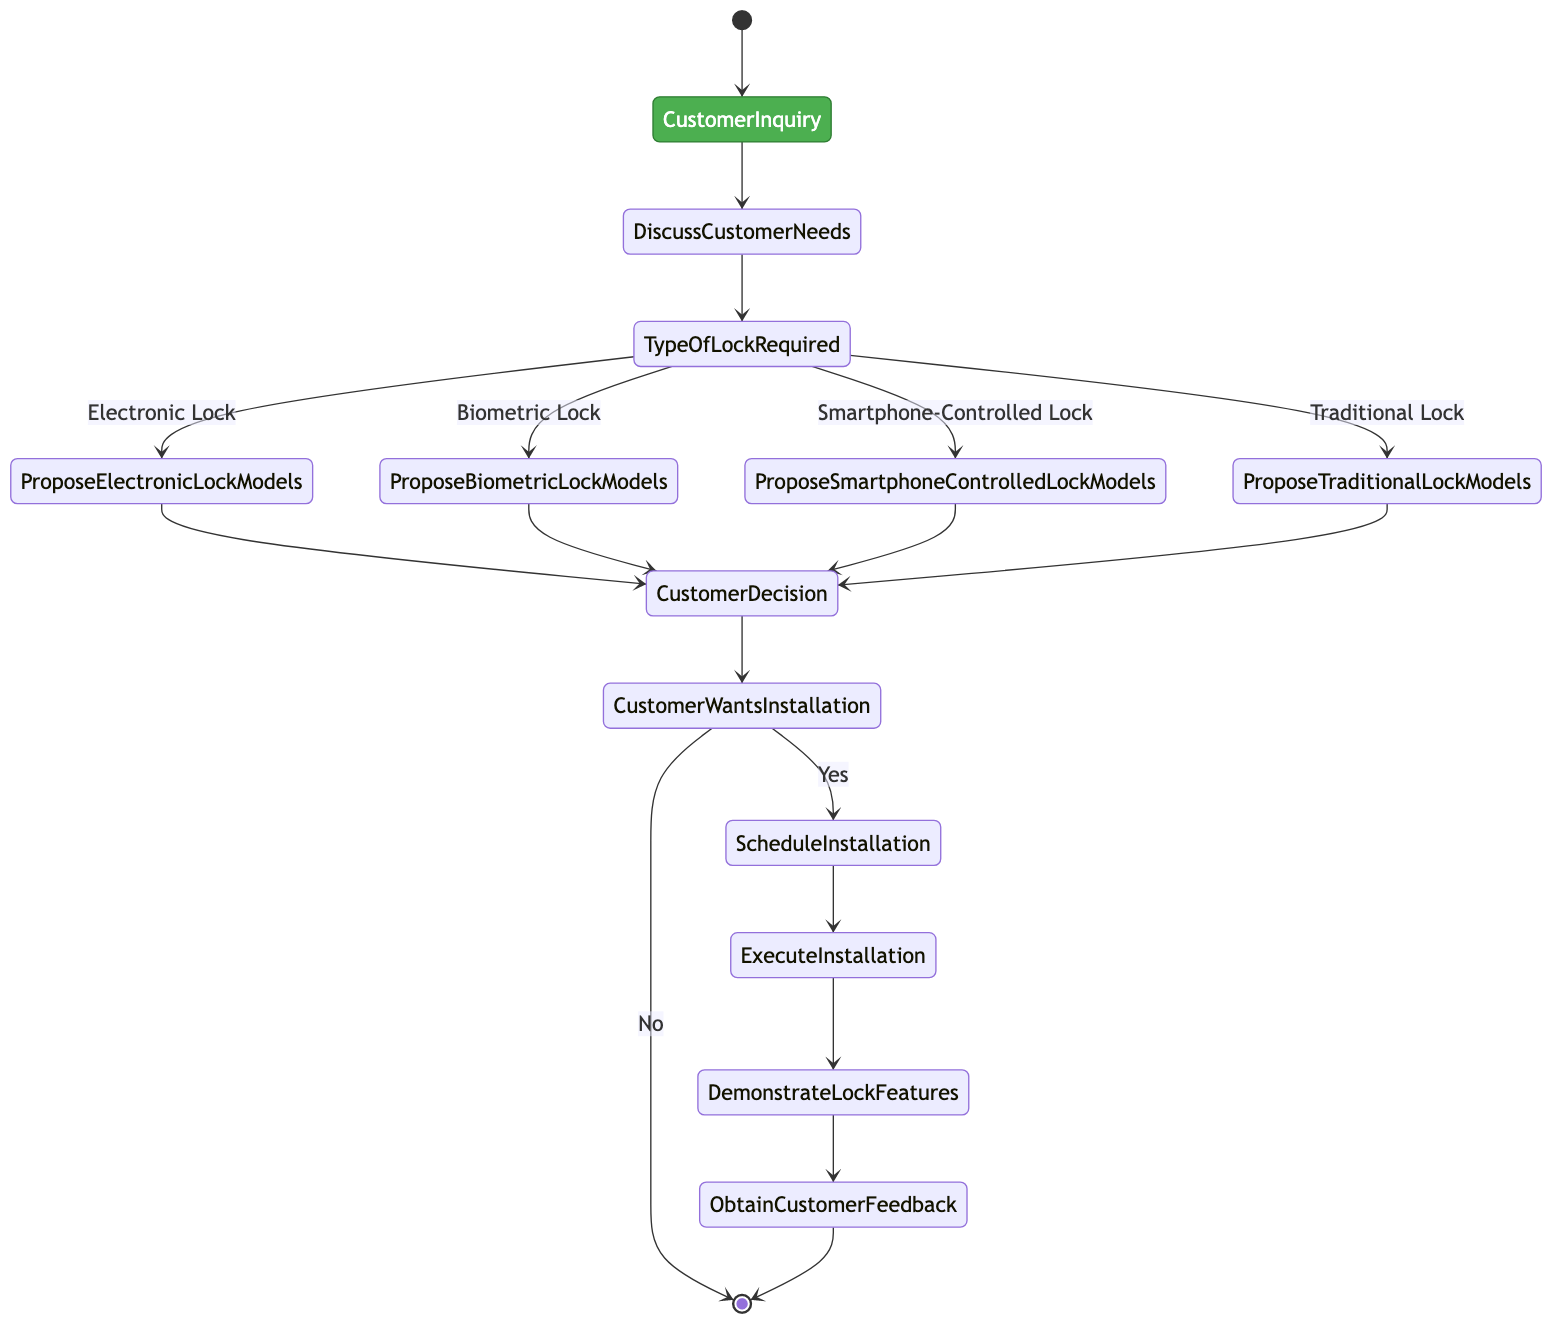What is the initial node in this workflow? The diagram starts with a node labeled "Customer Inquiry," which denotes the beginning of the workflow.
Answer: Customer Inquiry How many types of locks are proposed in this workflow? Four types of locks are proposed: Electronic Lock, Biometric Lock, Smartphone-Controlled Lock, and Traditional Lock, which indicates the available options for the customer.
Answer: Four What activity follows "Customer Decision"? After the "Customer Decision" activity, the decision node "Customer Wants Installation" takes place. It determines whether the customer proceeds with installation.
Answer: Customer Wants Installation In which activity does the installation take place? The installation takes place in the "Execute Installation" activity, where the lock is physically installed at the customer's location.
Answer: Execute Installation What happens if the customer does not want installation? If the customer does not want installation, the workflow ends, as indicated by the transition from "Customer Wants Installation" with the condition "No" leading directly to the "End" node.
Answer: End What must occur after the installation is executed? After the installation is executed, the "Demonstrate Lock Features" activity must occur, which involves showing the customer how to operate the newly installed lock.
Answer: Demonstrate Lock Features What is the final activity in this workflow? The final activity in the workflow is "Obtain Customer Feedback," which is meant to gather the customer's opinions and satisfaction regarding the installation and lock performance.
Answer: Obtain Customer Feedback What type of lock follows the decision for a Biometric Lock? Following the decision for a Biometric Lock, the next activity is "Propose Biometric Lock Models," where various options and features are presented to the customer.
Answer: Propose Biometric Lock Models What happens after "Schedule Installation"? After "Schedule Installation," the next activity is "Execute Installation," indicating that the planned installation date is followed by the actual installation process.
Answer: Execute Installation 